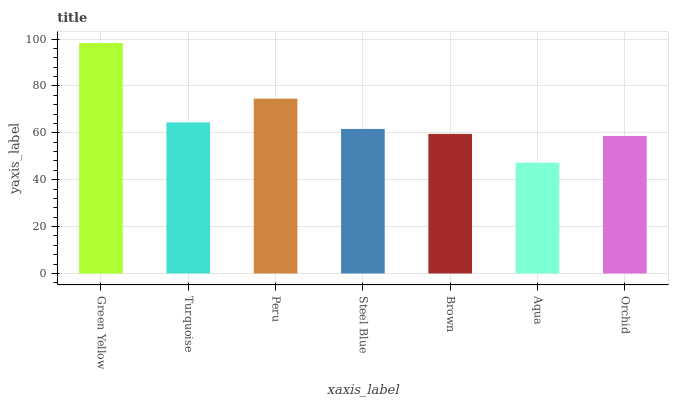Is Aqua the minimum?
Answer yes or no. Yes. Is Green Yellow the maximum?
Answer yes or no. Yes. Is Turquoise the minimum?
Answer yes or no. No. Is Turquoise the maximum?
Answer yes or no. No. Is Green Yellow greater than Turquoise?
Answer yes or no. Yes. Is Turquoise less than Green Yellow?
Answer yes or no. Yes. Is Turquoise greater than Green Yellow?
Answer yes or no. No. Is Green Yellow less than Turquoise?
Answer yes or no. No. Is Steel Blue the high median?
Answer yes or no. Yes. Is Steel Blue the low median?
Answer yes or no. Yes. Is Green Yellow the high median?
Answer yes or no. No. Is Turquoise the low median?
Answer yes or no. No. 